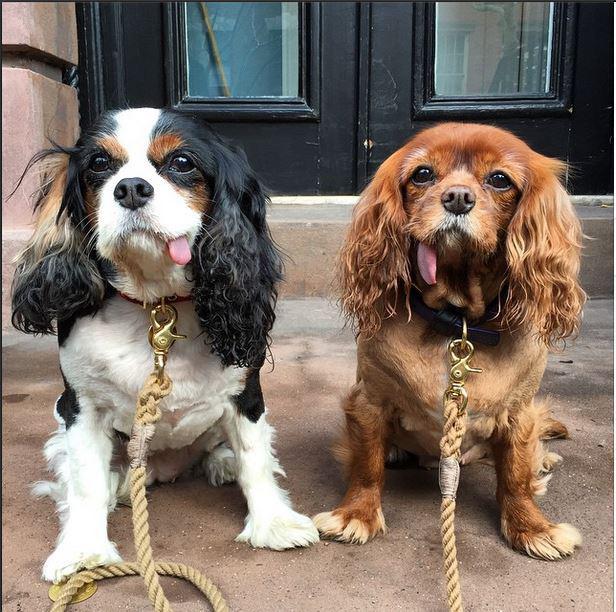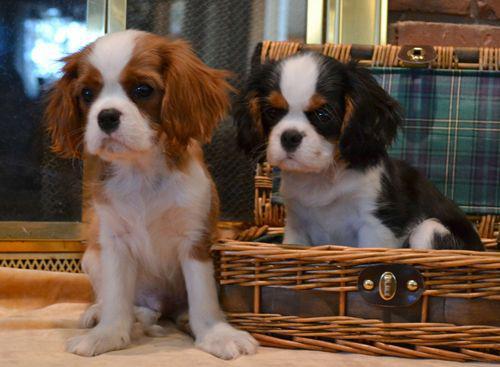The first image is the image on the left, the second image is the image on the right. Analyze the images presented: Is the assertion "There are no less than six cocker spaniels" valid? Answer yes or no. No. The first image is the image on the left, the second image is the image on the right. Evaluate the accuracy of this statement regarding the images: "At least two dogs are lying down in the image on the right.". Is it true? Answer yes or no. No. 